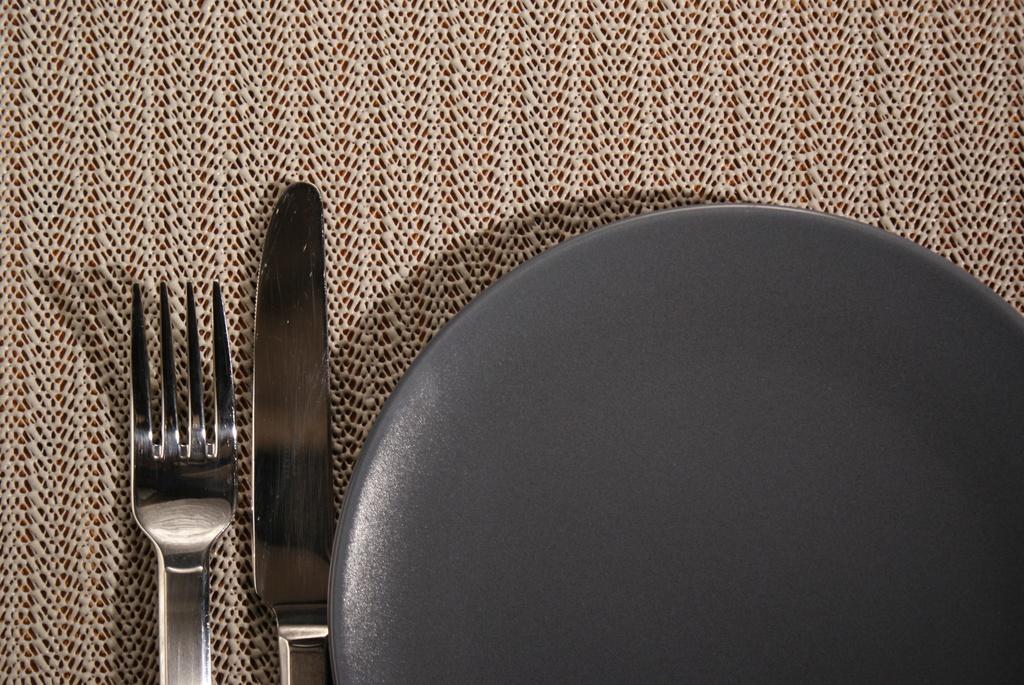Describe this image in one or two sentences. In the image we can see a plate gray in color, knife and a fork. This is a table mat. 